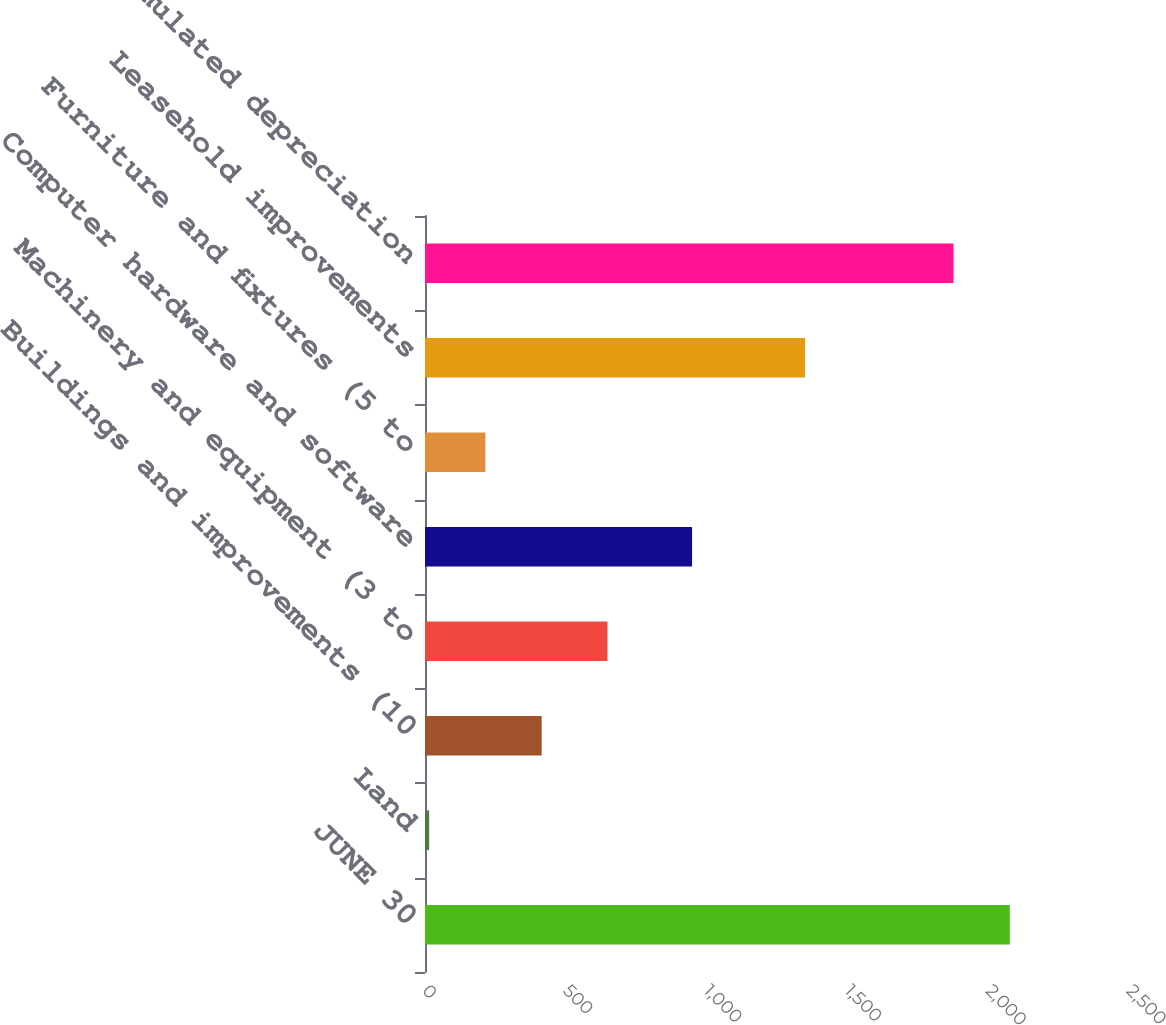<chart> <loc_0><loc_0><loc_500><loc_500><bar_chart><fcel>JUNE 30<fcel>Land<fcel>Buildings and improvements (10<fcel>Machinery and equipment (3 to<fcel>Computer hardware and software<fcel>Furniture and fixtures (5 to<fcel>Leasehold improvements<fcel>Less accumulated depreciation<nl><fcel>2076.73<fcel>14.7<fcel>414.36<fcel>647.9<fcel>948.4<fcel>214.53<fcel>1349.6<fcel>1876.9<nl></chart> 